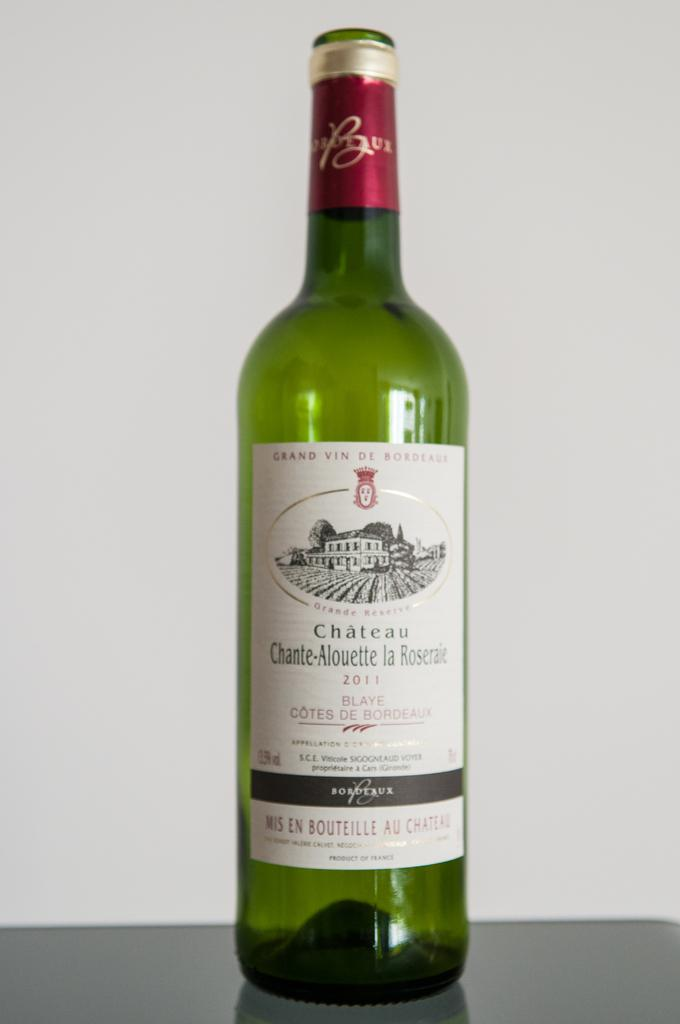<image>
Write a terse but informative summary of the picture. a bottle of wine with a label on it that says 'chateu chante-alouette la roserae' 